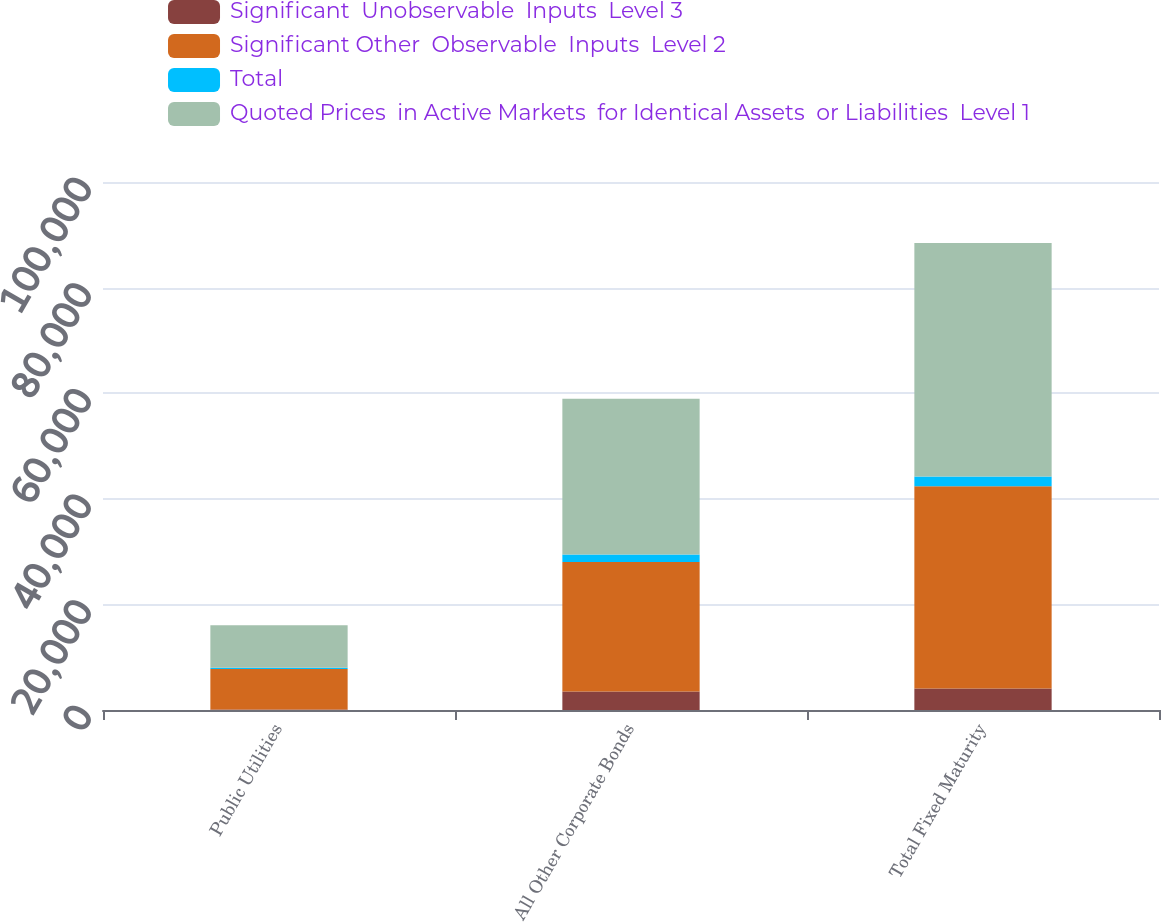<chart> <loc_0><loc_0><loc_500><loc_500><stacked_bar_chart><ecel><fcel>Public Utilities<fcel>All Other Corporate Bonds<fcel>Total Fixed Maturity<nl><fcel>Significant  Unobservable  Inputs  Level 3<fcel>108.5<fcel>3507.1<fcel>4069.8<nl><fcel>Significant Other  Observable  Inputs  Level 2<fcel>7648.9<fcel>24500.4<fcel>38309.8<nl><fcel>Total<fcel>265.3<fcel>1459.7<fcel>1837.7<nl><fcel>Quoted Prices  in Active Markets  for Identical Assets  or Liabilities  Level 1<fcel>8022.7<fcel>29467.2<fcel>44217.3<nl></chart> 